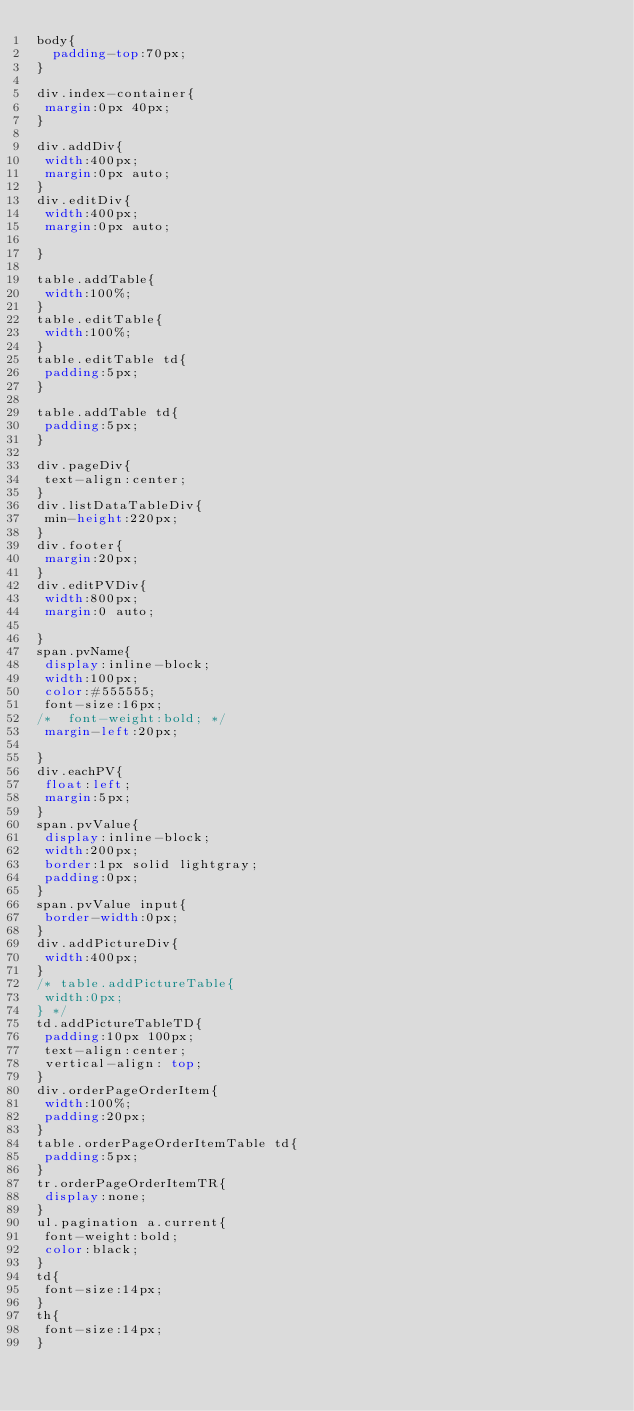<code> <loc_0><loc_0><loc_500><loc_500><_CSS_>body{
  padding-top:70px;
}

div.index-container{
 margin:0px 40px;
}

div.addDiv{
 width:400px;
 margin:0px auto;
}
div.editDiv{
 width:400px;
 margin:0px auto;

}

table.addTable{
 width:100%;
}
table.editTable{
 width:100%;
}
table.editTable td{
 padding:5px;
}

table.addTable td{
 padding:5px;
}

div.pageDiv{
 text-align:center;
}
div.listDataTableDiv{
 min-height:220px;
}
div.footer{
 margin:20px;
}
div.editPVDiv{
 width:800px;
 margin:0 auto;

}
span.pvName{
 display:inline-block;
 width:100px;
 color:#555555;
 font-size:16px;
/* 	font-weight:bold; */
 margin-left:20px;

}
div.eachPV{
 float:left;
 margin:5px;
}
span.pvValue{
 display:inline-block;
 width:200px;
 border:1px solid lightgray;
 padding:0px;
}
span.pvValue input{
 border-width:0px;
}
div.addPictureDiv{
 width:400px;
}
/* table.addPictureTable{
 width:0px;
} */
td.addPictureTableTD{
 padding:10px 100px;
 text-align:center;
 vertical-align: top;
}
div.orderPageOrderItem{
 width:100%;
 padding:20px;
}
table.orderPageOrderItemTable td{
 padding:5px;
}
tr.orderPageOrderItemTR{
 display:none;
}
ul.pagination a.current{
 font-weight:bold;
 color:black;
}
td{
 font-size:14px;
}
th{
 font-size:14px;
}
</code> 